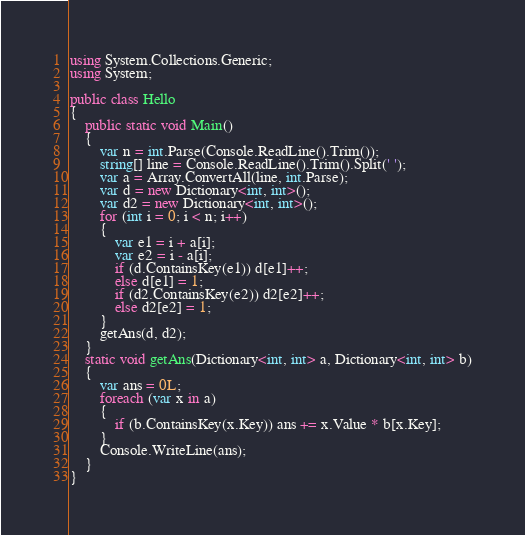<code> <loc_0><loc_0><loc_500><loc_500><_C#_>using System.Collections.Generic;
using System;

public class Hello
{
    public static void Main()
    {
        var n = int.Parse(Console.ReadLine().Trim());
        string[] line = Console.ReadLine().Trim().Split(' ');
        var a = Array.ConvertAll(line, int.Parse);
        var d = new Dictionary<int, int>();
        var d2 = new Dictionary<int, int>();
        for (int i = 0; i < n; i++)
        {
            var e1 = i + a[i];
            var e2 = i - a[i];
            if (d.ContainsKey(e1)) d[e1]++;
            else d[e1] = 1;
            if (d2.ContainsKey(e2)) d2[e2]++;
            else d2[e2] = 1;
        }
        getAns(d, d2);
    }
    static void getAns(Dictionary<int, int> a, Dictionary<int, int> b)
    {
        var ans = 0L;
        foreach (var x in a)
        {
            if (b.ContainsKey(x.Key)) ans += x.Value * b[x.Key];
        }
        Console.WriteLine(ans);
    }
}
</code> 